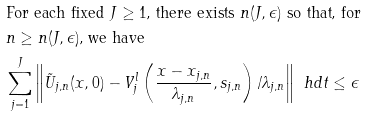<formula> <loc_0><loc_0><loc_500><loc_500>& \text {For each fixed $J\geq1$, there exists $n(J,\epsilon)$ so that, for } \\ & \text {$n\geq n(J,\epsilon)$, we have } \\ & \sum _ { j = 1 } ^ { J } \left \| \tilde { U } _ { j , n } ( x , 0 ) - V _ { j } ^ { l } \left ( \frac { x - x _ { j , n } } { \lambda _ { j , n } } , s _ { j , n } \right ) / \lambda _ { j , n } \right \| _ { \ } h d t \leq \epsilon</formula> 